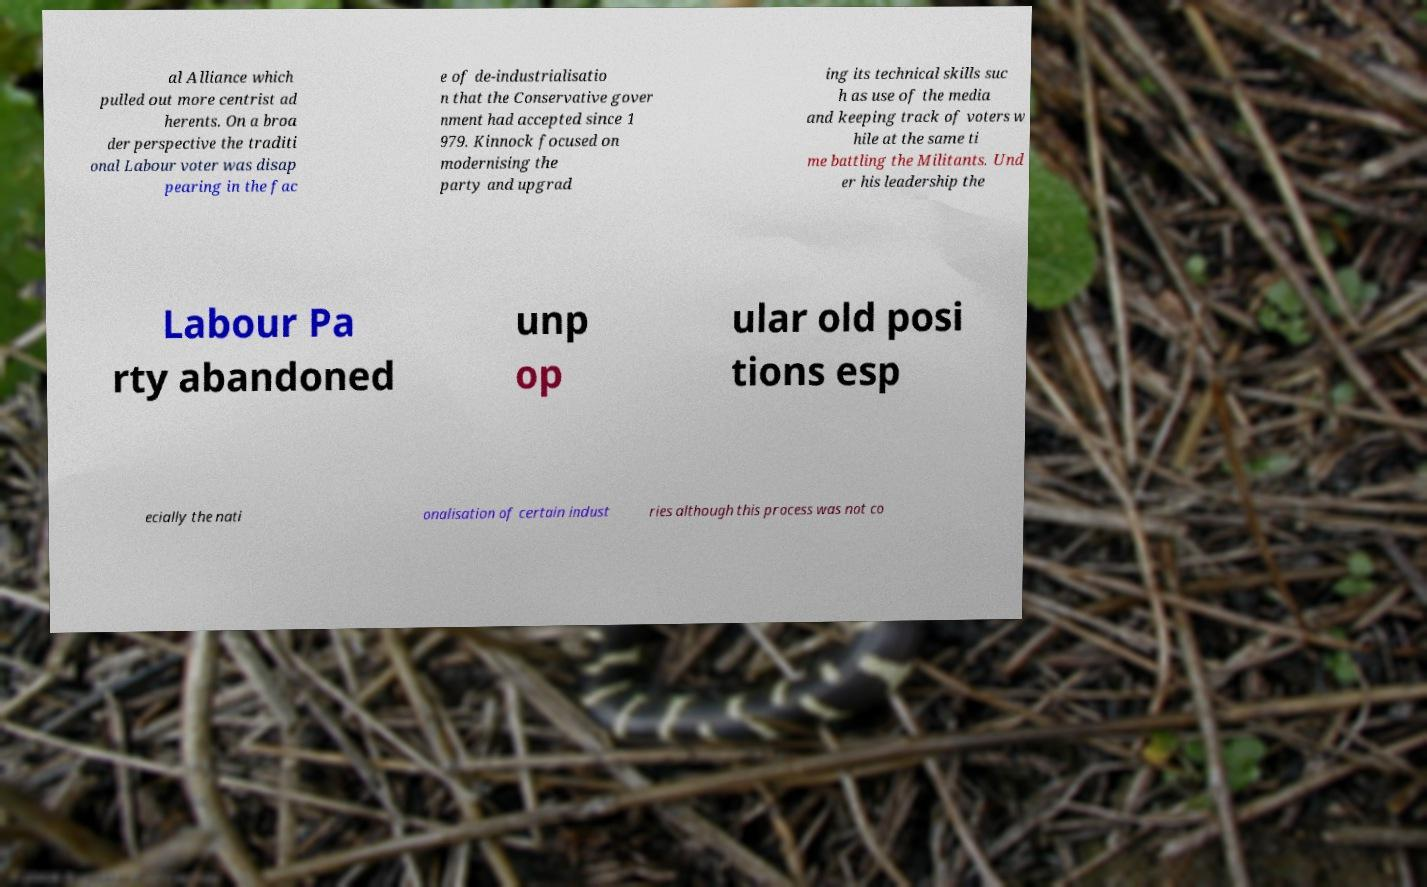Please read and relay the text visible in this image. What does it say? al Alliance which pulled out more centrist ad herents. On a broa der perspective the traditi onal Labour voter was disap pearing in the fac e of de-industrialisatio n that the Conservative gover nment had accepted since 1 979. Kinnock focused on modernising the party and upgrad ing its technical skills suc h as use of the media and keeping track of voters w hile at the same ti me battling the Militants. Und er his leadership the Labour Pa rty abandoned unp op ular old posi tions esp ecially the nati onalisation of certain indust ries although this process was not co 